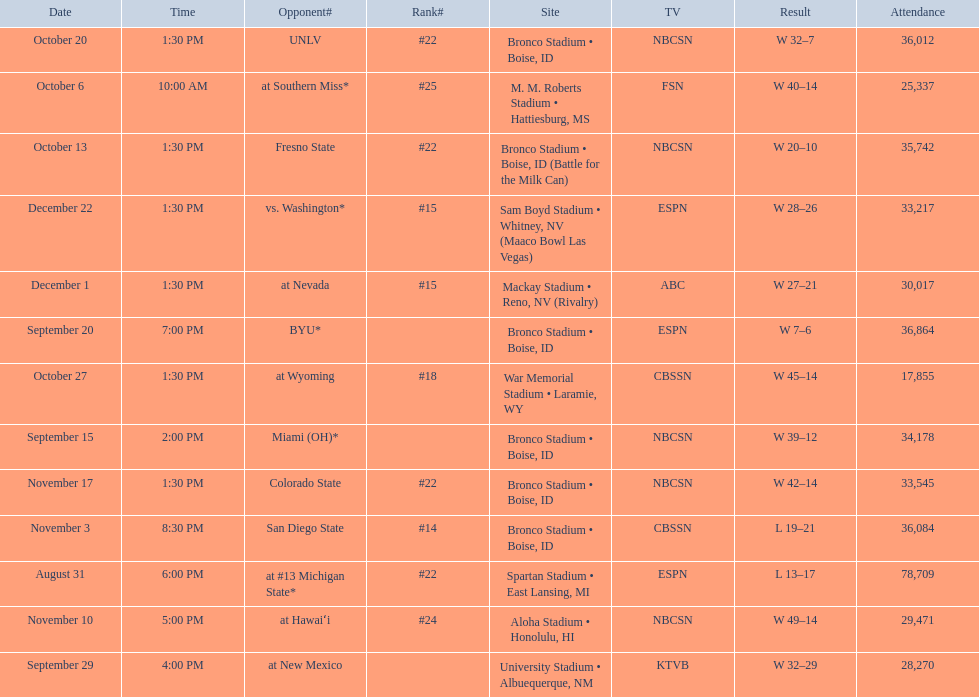What was the team's listed rankings for the season? #22, , , , #25, #22, #22, #18, #14, #24, #22, #15, #15. Which of these ranks is the best? #14. 